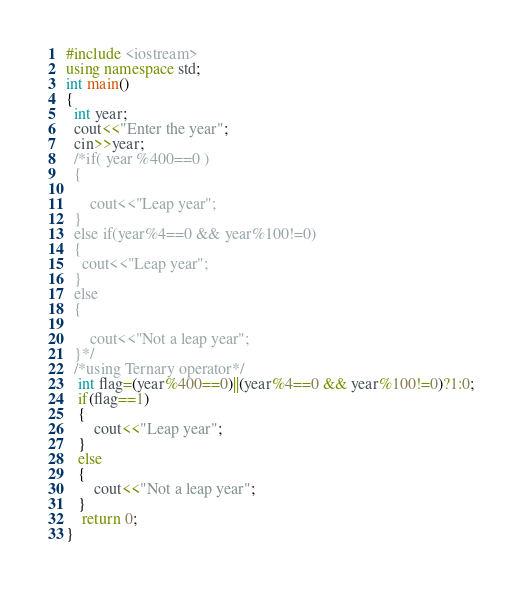Convert code to text. <code><loc_0><loc_0><loc_500><loc_500><_C++_>#include <iostream>
using namespace std;
int main()
{
  int year;
  cout<<"Enter the year";
  cin>>year;
  /*if( year %400==0 )
  {

      cout<<"Leap year";
  }
  else if(year%4==0 && year%100!=0)
  {
    cout<<"Leap year";
  }
  else
  {

      cout<<"Not a leap year";
  }*/
  /*using Ternary operator*/
   int flag=(year%400==0)||(year%4==0 && year%100!=0)?1:0;
   if(flag==1)
   {
       cout<<"Leap year";
   }
   else
   {
       cout<<"Not a leap year";
   }
    return 0;
}
</code> 